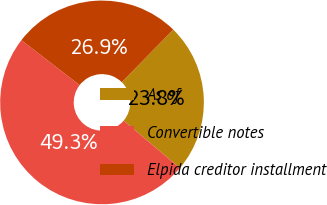Convert chart. <chart><loc_0><loc_0><loc_500><loc_500><pie_chart><fcel>As of<fcel>Convertible notes<fcel>Elpida creditor installment<nl><fcel>23.83%<fcel>49.32%<fcel>26.86%<nl></chart> 